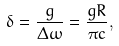Convert formula to latex. <formula><loc_0><loc_0><loc_500><loc_500>\delta = \frac { g } { \Delta \omega } = \frac { g R } { \pi c } ,</formula> 